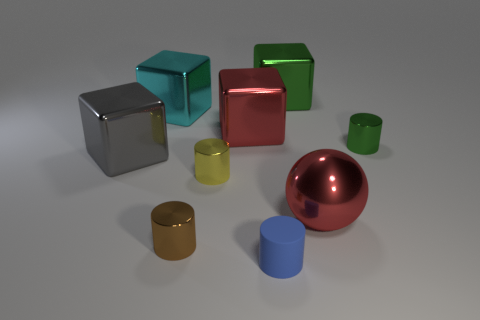There is a cube that is to the left of the cyan metal cube; is it the same size as the big red shiny sphere?
Provide a short and direct response. Yes. What number of other objects are there of the same size as the yellow thing?
Your response must be concise. 3. The small matte object is what color?
Your answer should be very brief. Blue. What is the material of the small object in front of the small brown metal cylinder?
Offer a terse response. Rubber. Are there an equal number of red cubes that are to the left of the red block and spheres?
Your answer should be compact. No. Do the gray shiny object and the matte thing have the same shape?
Your response must be concise. No. Is there any other thing that is the same color as the shiny ball?
Offer a terse response. Yes. What is the shape of the metallic object that is right of the small yellow shiny thing and left of the tiny blue cylinder?
Give a very brief answer. Cube. Is the number of tiny yellow shiny cylinders in front of the large ball the same as the number of metal things right of the big green cube?
Provide a short and direct response. No. What number of cubes are red metal things or green metallic objects?
Give a very brief answer. 2. 